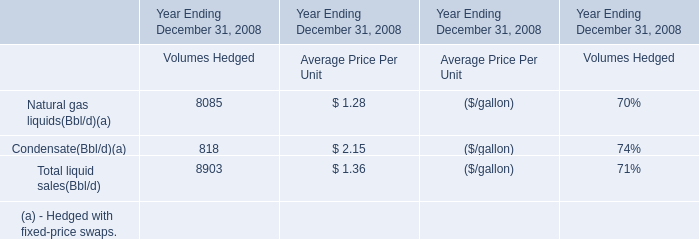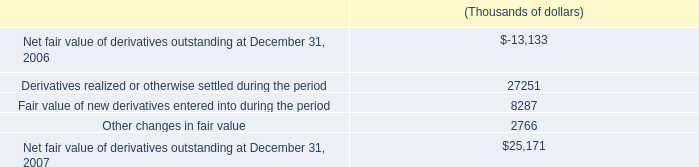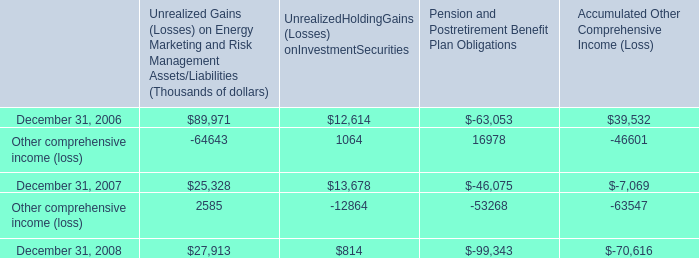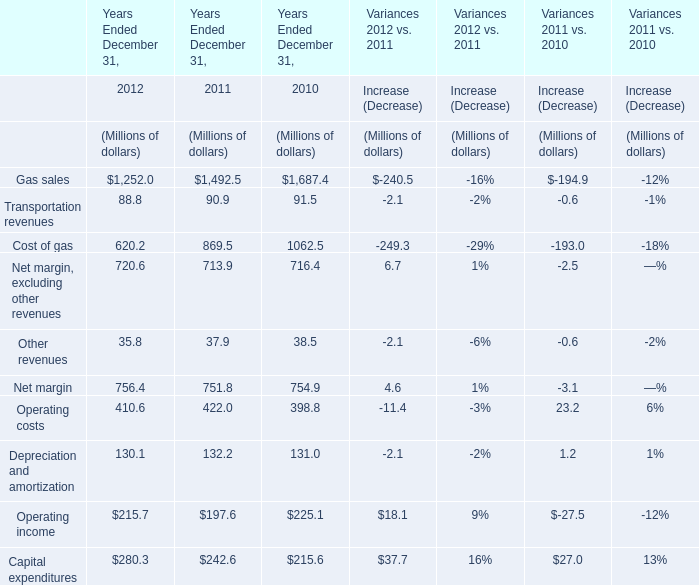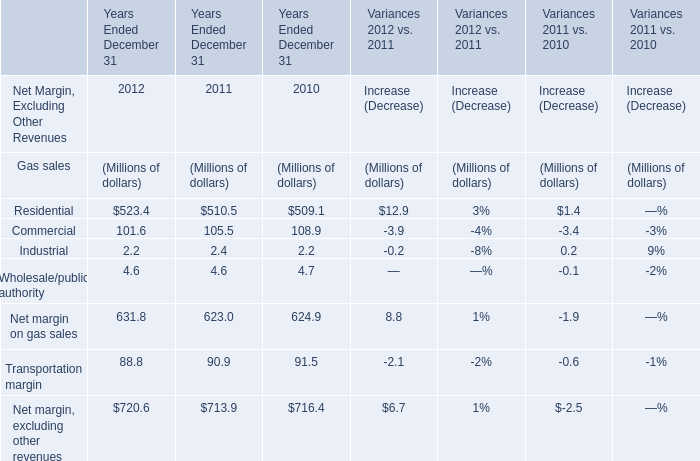What is the sum of the Net margin in the years where Gas sales greater than 1600? (in million) 
Computations: (716.4 + 38.5)
Answer: 754.9. 